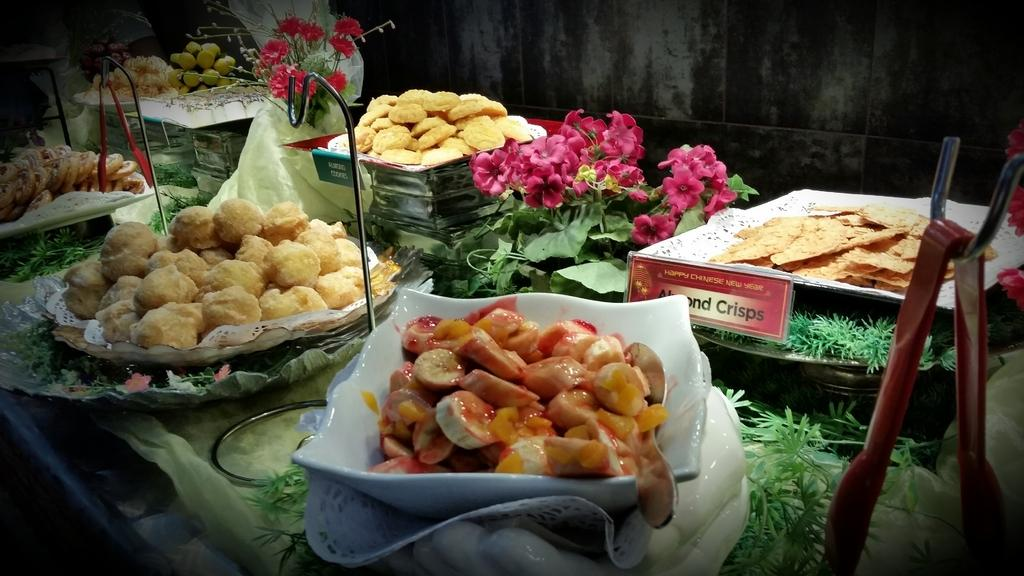What objects are present in the image that contain food items? There are bowls in the image that contain food items. What else can be seen in the middle of the image besides the bowls? There are flowers in the middle of the image. What type of lip can be seen on the food items in the image? There are no lips present on the food items in the image. 